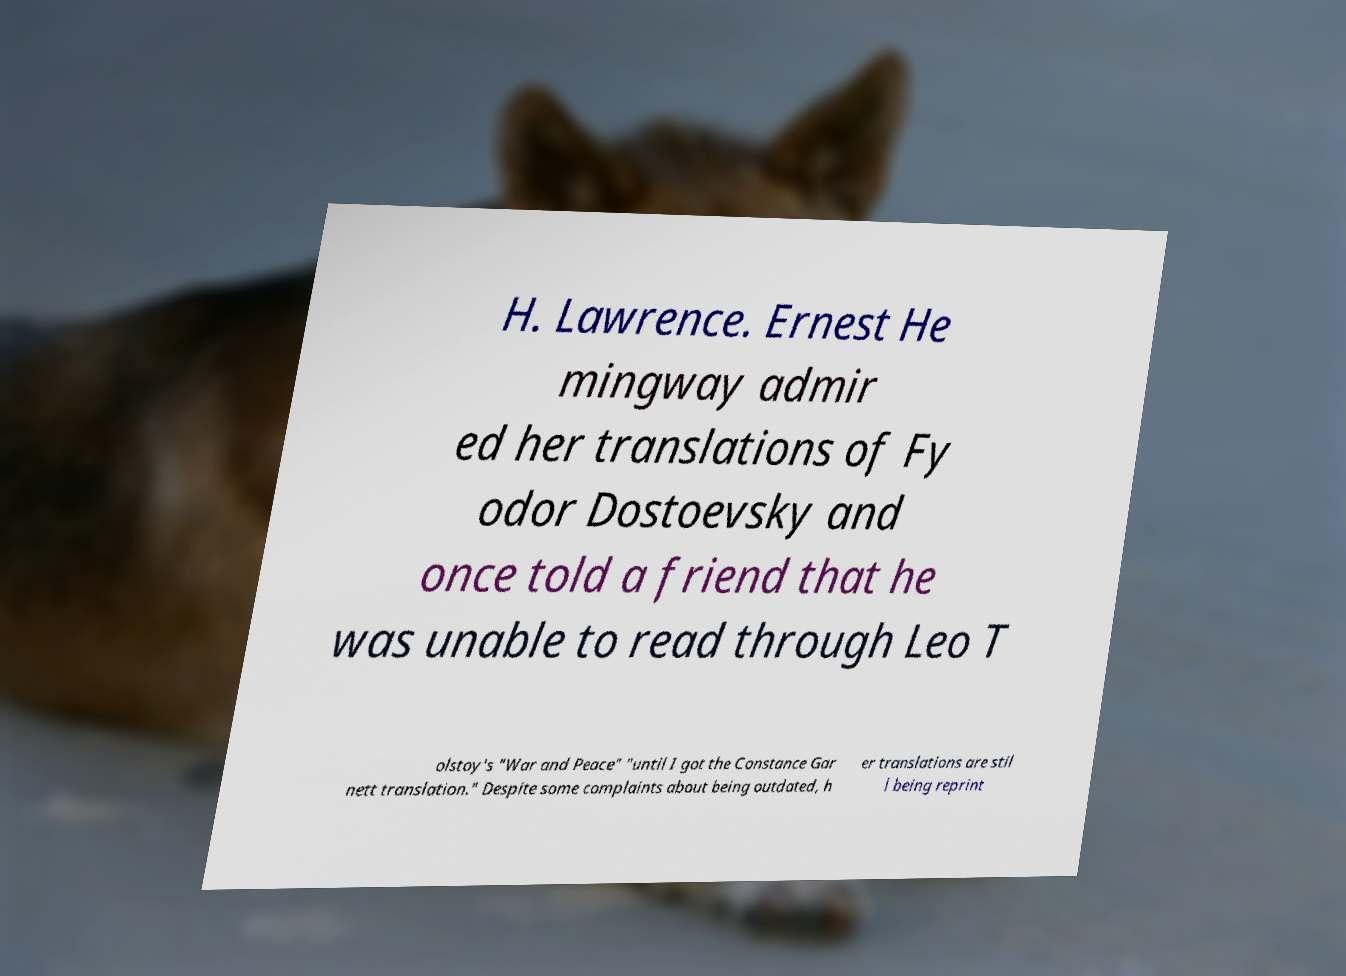There's text embedded in this image that I need extracted. Can you transcribe it verbatim? H. Lawrence. Ernest He mingway admir ed her translations of Fy odor Dostoevsky and once told a friend that he was unable to read through Leo T olstoy's "War and Peace" "until I got the Constance Gar nett translation." Despite some complaints about being outdated, h er translations are stil l being reprint 